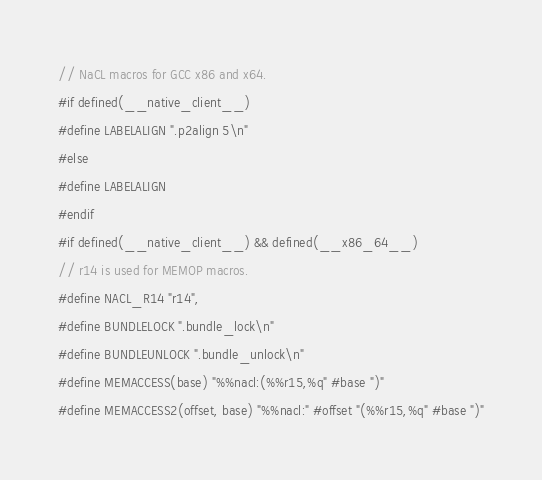<code> <loc_0><loc_0><loc_500><loc_500><_C_>
// NaCL macros for GCC x86 and x64.
#if defined(__native_client__)
#define LABELALIGN ".p2align 5\n"
#else
#define LABELALIGN
#endif
#if defined(__native_client__) && defined(__x86_64__)
// r14 is used for MEMOP macros.
#define NACL_R14 "r14",
#define BUNDLELOCK ".bundle_lock\n"
#define BUNDLEUNLOCK ".bundle_unlock\n"
#define MEMACCESS(base) "%%nacl:(%%r15,%q" #base ")"
#define MEMACCESS2(offset, base) "%%nacl:" #offset "(%%r15,%q" #base ")"</code> 